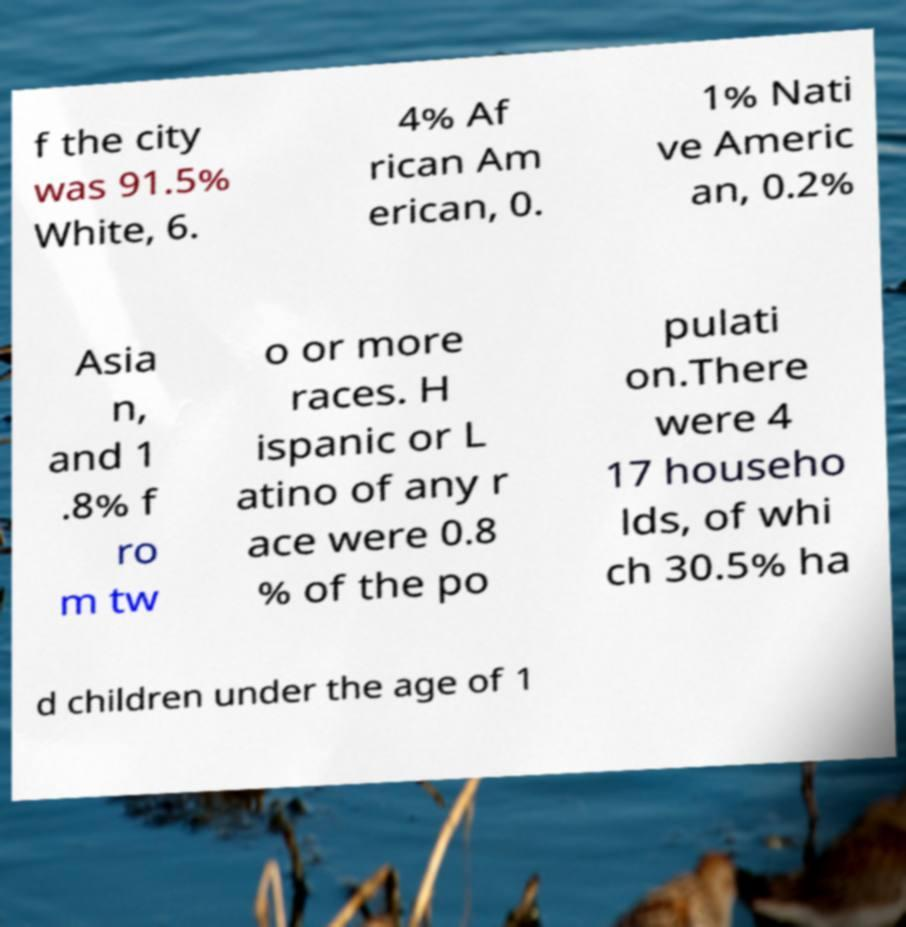There's text embedded in this image that I need extracted. Can you transcribe it verbatim? f the city was 91.5% White, 6. 4% Af rican Am erican, 0. 1% Nati ve Americ an, 0.2% Asia n, and 1 .8% f ro m tw o or more races. H ispanic or L atino of any r ace were 0.8 % of the po pulati on.There were 4 17 househo lds, of whi ch 30.5% ha d children under the age of 1 